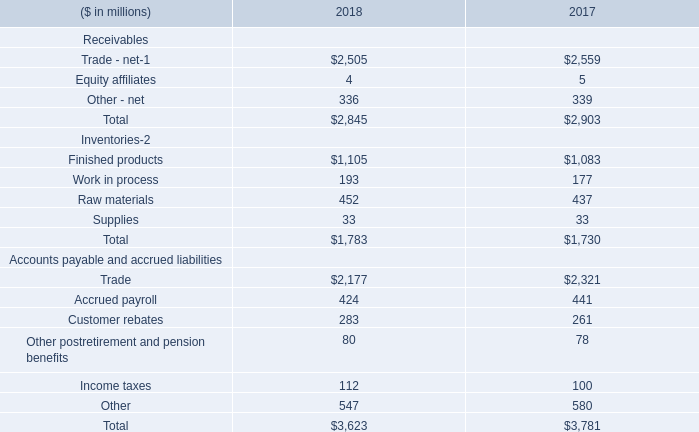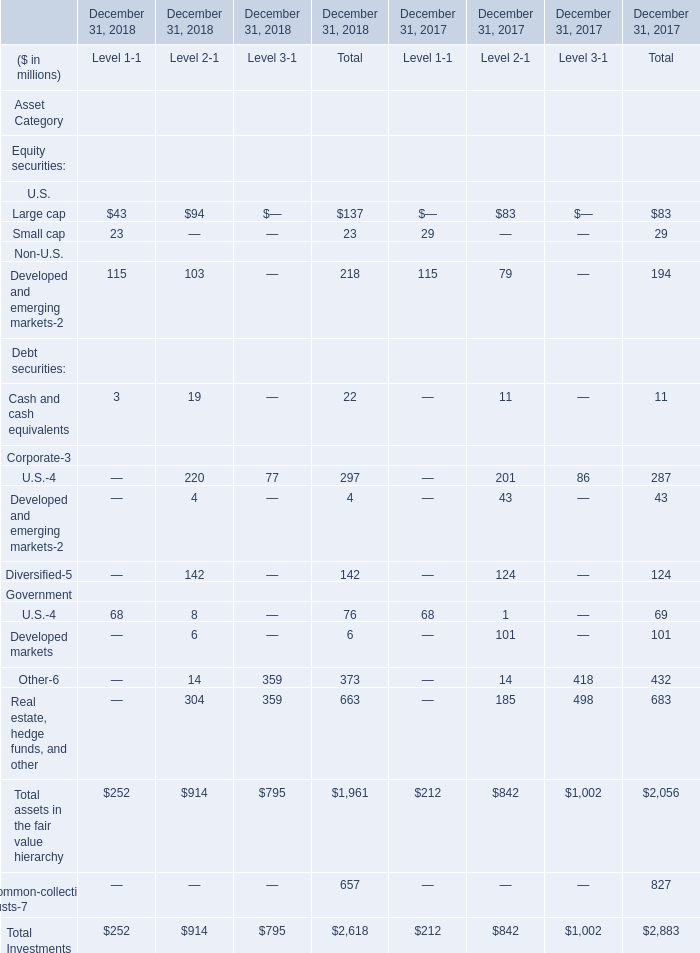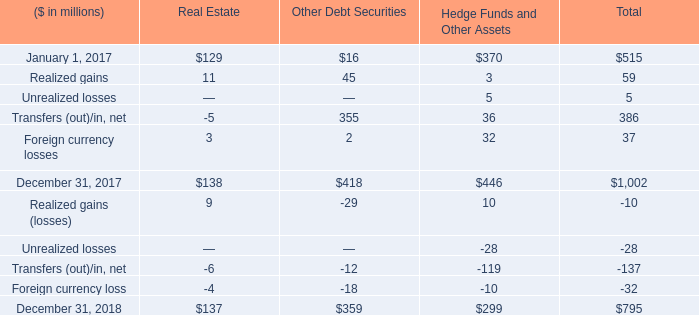What is the sum of Real Estate Other Debt Securities Hedge Funds and Other Assets in 2017 ? 
Computations: ((129 + 16) + 370)
Answer: 515.0. 